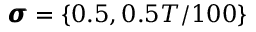<formula> <loc_0><loc_0><loc_500><loc_500>\pm b { \sigma } = \{ 0 . 5 , 0 . 5 T / 1 0 0 \}</formula> 